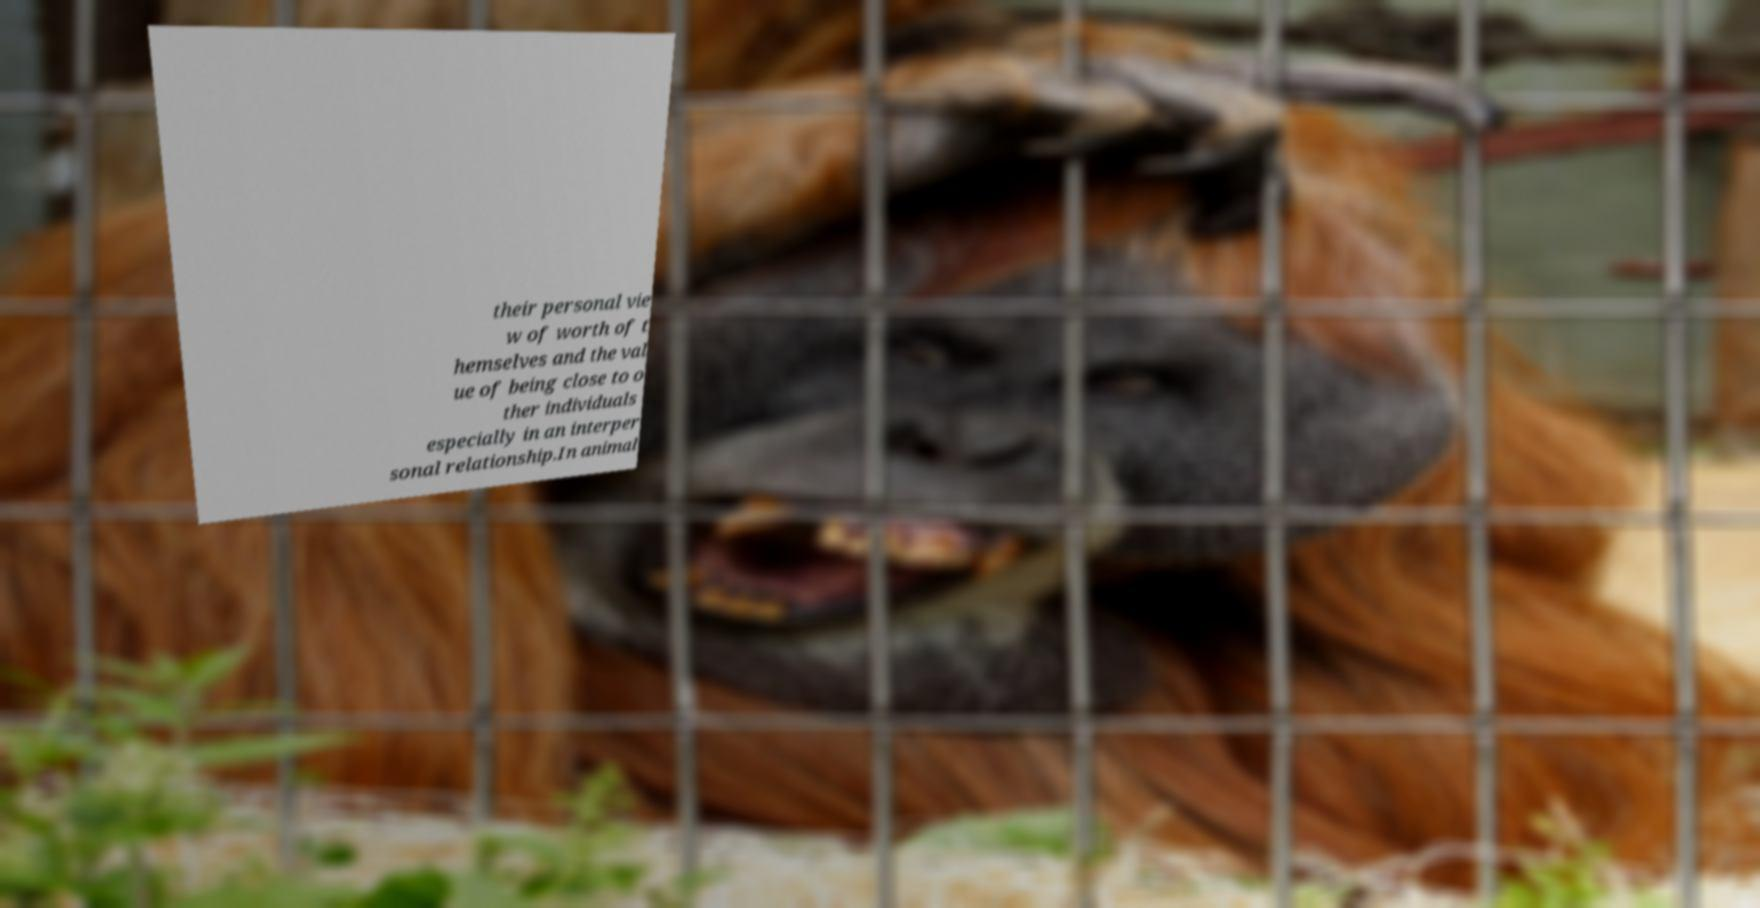I need the written content from this picture converted into text. Can you do that? their personal vie w of worth of t hemselves and the val ue of being close to o ther individuals especially in an interper sonal relationship.In animal 